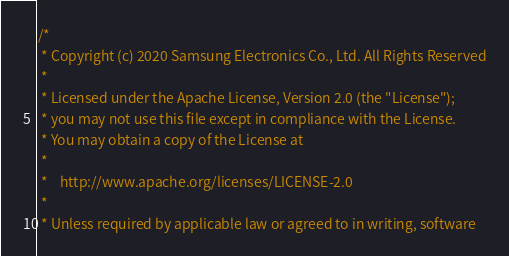<code> <loc_0><loc_0><loc_500><loc_500><_C++_>/*
 * Copyright (c) 2020 Samsung Electronics Co., Ltd. All Rights Reserved
 *
 * Licensed under the Apache License, Version 2.0 (the "License");
 * you may not use this file except in compliance with the License.
 * You may obtain a copy of the License at
 *
 *    http://www.apache.org/licenses/LICENSE-2.0
 *
 * Unless required by applicable law or agreed to in writing, software</code> 